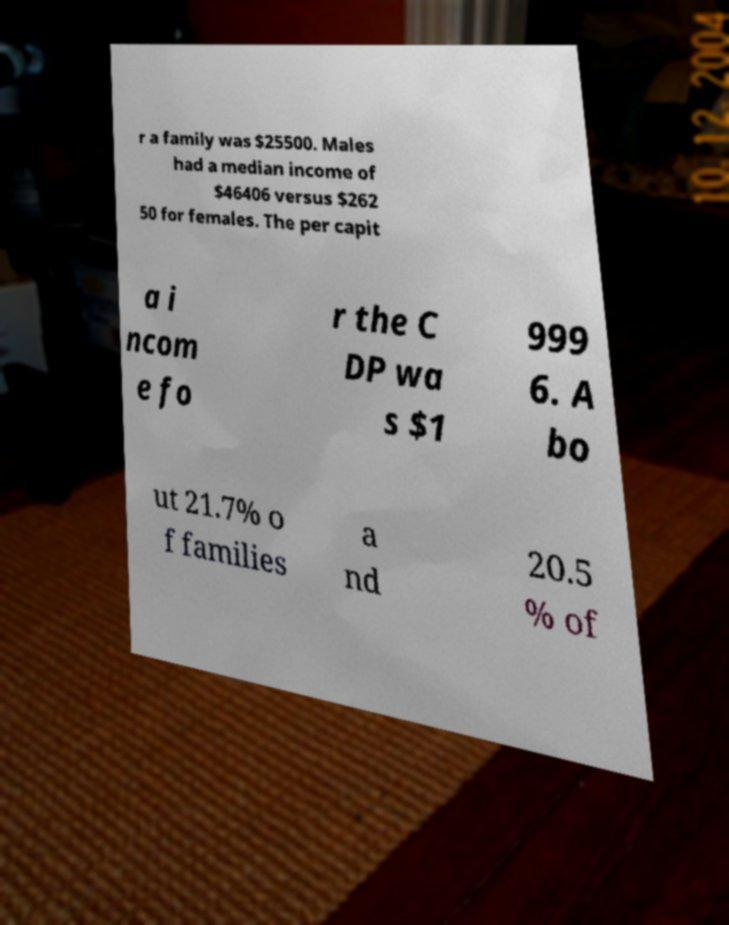Can you read and provide the text displayed in the image?This photo seems to have some interesting text. Can you extract and type it out for me? r a family was $25500. Males had a median income of $46406 versus $262 50 for females. The per capit a i ncom e fo r the C DP wa s $1 999 6. A bo ut 21.7% o f families a nd 20.5 % of 